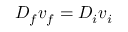Convert formula to latex. <formula><loc_0><loc_0><loc_500><loc_500>D _ { f } v _ { f } = D _ { i } v _ { i }</formula> 